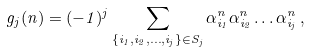Convert formula to latex. <formula><loc_0><loc_0><loc_500><loc_500>g _ { j } ( n ) = ( - 1 ) ^ { j } \sum _ { \{ i _ { 1 } , i _ { 2 } , \dots , i _ { j } \} \in S _ { j } } \alpha _ { i _ { 1 } } ^ { n } \alpha _ { i _ { 2 } } ^ { n } \dots \alpha _ { i _ { j } } ^ { n } \, ,</formula> 